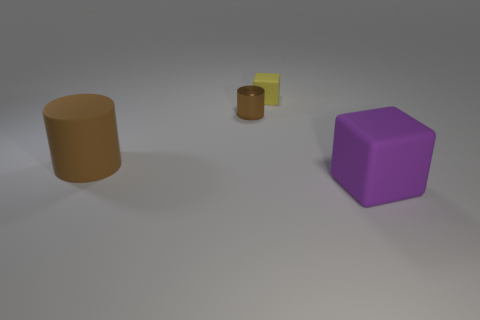Add 1 blue metal balls. How many objects exist? 5 Subtract all yellow blocks. How many blocks are left? 1 Add 1 large matte things. How many large matte things are left? 3 Add 4 small objects. How many small objects exist? 6 Subtract 2 brown cylinders. How many objects are left? 2 Subtract 2 cylinders. How many cylinders are left? 0 Subtract all yellow cylinders. Subtract all gray cubes. How many cylinders are left? 2 Subtract all red balls. How many purple cubes are left? 1 Subtract all yellow objects. Subtract all purple matte blocks. How many objects are left? 2 